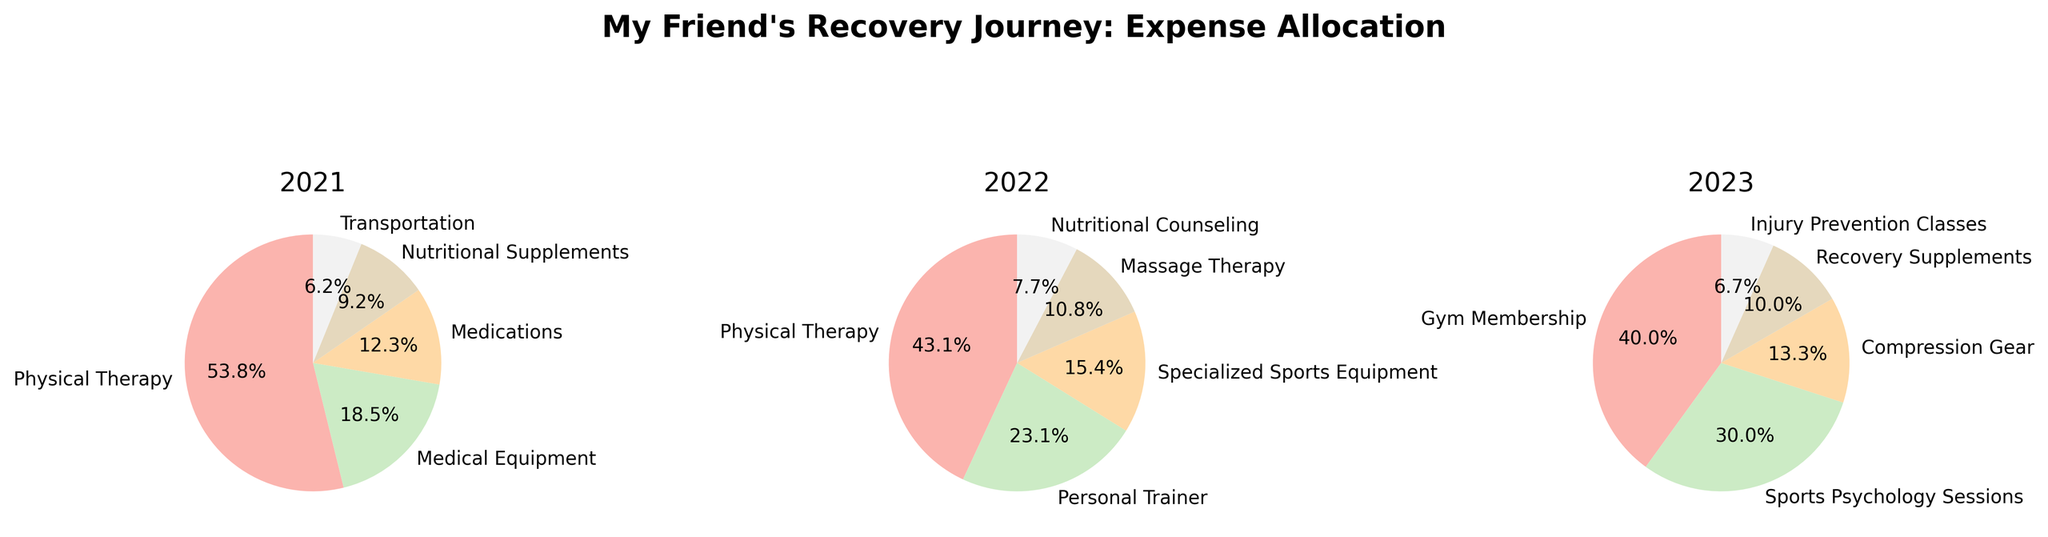What's the title of the figure? The title is displayed at the top center of the figure. It reads "My Friend's Recovery Journey: Expense Allocation".
Answer: "My Friend's Recovery Journey: Expense Allocation" What year allocated the most money for Physical Therapy? In the pie chart for 2021, Physical Therapy is a large segment. In 2022, it is significant but smaller than 2021. In 2023, Physical Therapy doesn't appear at all. Therefore, 2021 allocated the most for Physical Therapy.
Answer: 2021 Which year had the most categories of expenses? We can count the number of labels in each year's pie chart. 2021 has 5 categories, 2022 has 5, and 2023 has 5. So all years have the same number of categories.
Answer: They all have the same number What percentage of the 2022 expenses went to a Personal Trainer? Looking at the 2022 pie chart, the segment labeled Personal Trainer says 28.3%. This shows the percentage of total expenses.
Answer: 28.3% Compare the proportion of expenses for Physical Therapy in 2021 and 2022. Which year had a higher proportion? By examining the pie charts for 2021 and 2022, Physical Therapy constitutes a larger section in the 2021 pie chart compared to the 2022 pie chart, so 2021 had a higher proportion.
Answer: 2021 Which type of expense was most prominent in 2023? In the 2023 pie chart, the largest slice is for Gym Membership. Thus, the most prominent expense type in the visual is Gym Membership.
Answer: Gym Membership If we combine spending on Nutritional Supplements in 2021 and Nutritional Counseling in 2022, what is the total amount? Nutritional Supplements in 2021 is 600, and Nutritional Counseling in 2022 is 500. Adding these amounts: 600 + 500 = 1100.
Answer: 1100 How does the total expense for Medical Equipment in 2021 compare to Specialized Sports Equipment in 2022? Medical Equipment in 2021 is 1200, and Specialized Sports Equipment in 2022 is 1000. Therefore, Medical Equipment in 2021 has a higher expense by 200.
Answer: Medical Equipment in 2021 What category forms 50% of the total expenses in any year? By analyzing the pie charts, no category in any year forms exactly 50% of the total expenses.
Answer: None Which year has the lowest individual expense category? The smallest individual expense is Injury Prevention Classes in 2023 at 200. Comparing it with all other categories, 2023 has the lowest individual expense.
Answer: 2023 